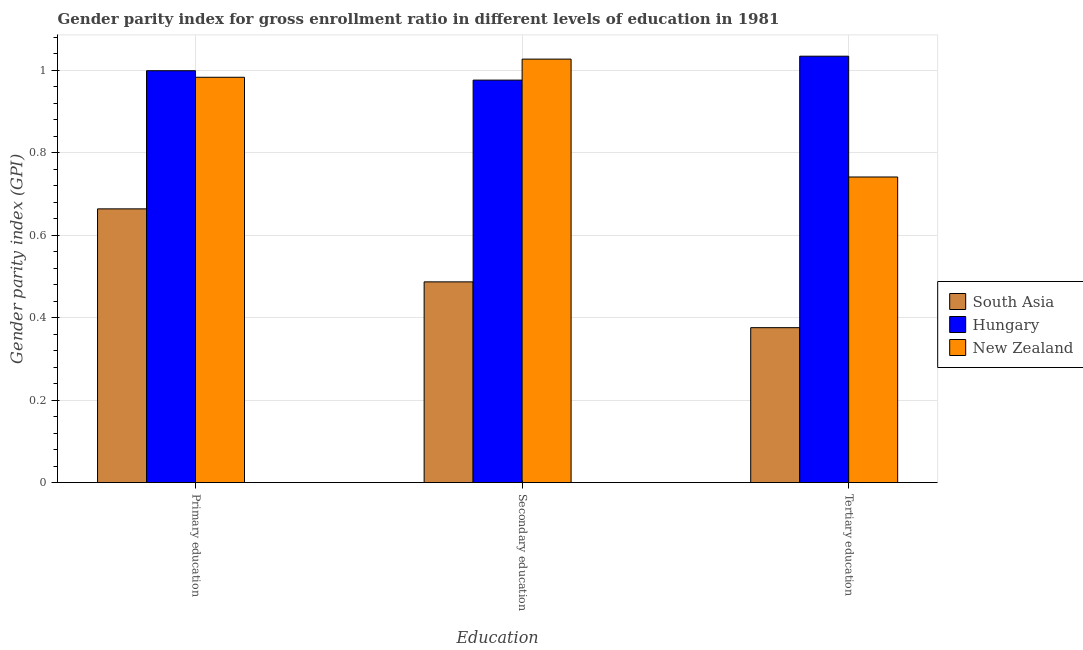How many different coloured bars are there?
Provide a succinct answer. 3. Are the number of bars on each tick of the X-axis equal?
Keep it short and to the point. Yes. How many bars are there on the 1st tick from the left?
Your response must be concise. 3. How many bars are there on the 3rd tick from the right?
Offer a very short reply. 3. What is the label of the 1st group of bars from the left?
Offer a very short reply. Primary education. What is the gender parity index in secondary education in New Zealand?
Offer a very short reply. 1.03. Across all countries, what is the maximum gender parity index in primary education?
Offer a terse response. 1. Across all countries, what is the minimum gender parity index in tertiary education?
Keep it short and to the point. 0.38. In which country was the gender parity index in primary education maximum?
Make the answer very short. Hungary. What is the total gender parity index in primary education in the graph?
Your response must be concise. 2.64. What is the difference between the gender parity index in tertiary education in New Zealand and that in Hungary?
Your answer should be very brief. -0.29. What is the difference between the gender parity index in primary education in New Zealand and the gender parity index in tertiary education in South Asia?
Ensure brevity in your answer.  0.61. What is the average gender parity index in tertiary education per country?
Ensure brevity in your answer.  0.72. What is the difference between the gender parity index in primary education and gender parity index in tertiary education in New Zealand?
Give a very brief answer. 0.24. What is the ratio of the gender parity index in tertiary education in South Asia to that in Hungary?
Offer a very short reply. 0.36. Is the gender parity index in tertiary education in New Zealand less than that in Hungary?
Give a very brief answer. Yes. What is the difference between the highest and the second highest gender parity index in primary education?
Offer a terse response. 0.02. What is the difference between the highest and the lowest gender parity index in tertiary education?
Offer a very short reply. 0.66. Is the sum of the gender parity index in tertiary education in Hungary and New Zealand greater than the maximum gender parity index in primary education across all countries?
Keep it short and to the point. Yes. What does the 3rd bar from the left in Tertiary education represents?
Provide a succinct answer. New Zealand. What does the 2nd bar from the right in Tertiary education represents?
Your response must be concise. Hungary. How many bars are there?
Offer a very short reply. 9. How many countries are there in the graph?
Offer a very short reply. 3. What is the difference between two consecutive major ticks on the Y-axis?
Provide a short and direct response. 0.2. Does the graph contain any zero values?
Your response must be concise. No. Does the graph contain grids?
Keep it short and to the point. Yes. How many legend labels are there?
Offer a very short reply. 3. How are the legend labels stacked?
Offer a terse response. Vertical. What is the title of the graph?
Your answer should be compact. Gender parity index for gross enrollment ratio in different levels of education in 1981. Does "Hong Kong" appear as one of the legend labels in the graph?
Your response must be concise. No. What is the label or title of the X-axis?
Provide a short and direct response. Education. What is the label or title of the Y-axis?
Provide a short and direct response. Gender parity index (GPI). What is the Gender parity index (GPI) in South Asia in Primary education?
Offer a terse response. 0.66. What is the Gender parity index (GPI) in Hungary in Primary education?
Your answer should be compact. 1. What is the Gender parity index (GPI) in New Zealand in Primary education?
Provide a short and direct response. 0.98. What is the Gender parity index (GPI) in South Asia in Secondary education?
Offer a very short reply. 0.49. What is the Gender parity index (GPI) of Hungary in Secondary education?
Your answer should be very brief. 0.98. What is the Gender parity index (GPI) of New Zealand in Secondary education?
Give a very brief answer. 1.03. What is the Gender parity index (GPI) in South Asia in Tertiary education?
Offer a very short reply. 0.38. What is the Gender parity index (GPI) in Hungary in Tertiary education?
Keep it short and to the point. 1.03. What is the Gender parity index (GPI) in New Zealand in Tertiary education?
Keep it short and to the point. 0.74. Across all Education, what is the maximum Gender parity index (GPI) of South Asia?
Give a very brief answer. 0.66. Across all Education, what is the maximum Gender parity index (GPI) in Hungary?
Offer a very short reply. 1.03. Across all Education, what is the maximum Gender parity index (GPI) of New Zealand?
Give a very brief answer. 1.03. Across all Education, what is the minimum Gender parity index (GPI) of South Asia?
Your answer should be very brief. 0.38. Across all Education, what is the minimum Gender parity index (GPI) in Hungary?
Your answer should be very brief. 0.98. Across all Education, what is the minimum Gender parity index (GPI) in New Zealand?
Give a very brief answer. 0.74. What is the total Gender parity index (GPI) in South Asia in the graph?
Your answer should be compact. 1.53. What is the total Gender parity index (GPI) in Hungary in the graph?
Make the answer very short. 3.01. What is the total Gender parity index (GPI) in New Zealand in the graph?
Give a very brief answer. 2.75. What is the difference between the Gender parity index (GPI) in South Asia in Primary education and that in Secondary education?
Offer a very short reply. 0.18. What is the difference between the Gender parity index (GPI) in Hungary in Primary education and that in Secondary education?
Keep it short and to the point. 0.02. What is the difference between the Gender parity index (GPI) in New Zealand in Primary education and that in Secondary education?
Provide a succinct answer. -0.04. What is the difference between the Gender parity index (GPI) in South Asia in Primary education and that in Tertiary education?
Make the answer very short. 0.29. What is the difference between the Gender parity index (GPI) of Hungary in Primary education and that in Tertiary education?
Your answer should be very brief. -0.04. What is the difference between the Gender parity index (GPI) of New Zealand in Primary education and that in Tertiary education?
Provide a short and direct response. 0.24. What is the difference between the Gender parity index (GPI) of South Asia in Secondary education and that in Tertiary education?
Your answer should be compact. 0.11. What is the difference between the Gender parity index (GPI) in Hungary in Secondary education and that in Tertiary education?
Make the answer very short. -0.06. What is the difference between the Gender parity index (GPI) of New Zealand in Secondary education and that in Tertiary education?
Provide a short and direct response. 0.29. What is the difference between the Gender parity index (GPI) of South Asia in Primary education and the Gender parity index (GPI) of Hungary in Secondary education?
Provide a short and direct response. -0.31. What is the difference between the Gender parity index (GPI) in South Asia in Primary education and the Gender parity index (GPI) in New Zealand in Secondary education?
Ensure brevity in your answer.  -0.36. What is the difference between the Gender parity index (GPI) of Hungary in Primary education and the Gender parity index (GPI) of New Zealand in Secondary education?
Your answer should be very brief. -0.03. What is the difference between the Gender parity index (GPI) of South Asia in Primary education and the Gender parity index (GPI) of Hungary in Tertiary education?
Keep it short and to the point. -0.37. What is the difference between the Gender parity index (GPI) in South Asia in Primary education and the Gender parity index (GPI) in New Zealand in Tertiary education?
Give a very brief answer. -0.08. What is the difference between the Gender parity index (GPI) of Hungary in Primary education and the Gender parity index (GPI) of New Zealand in Tertiary education?
Provide a succinct answer. 0.26. What is the difference between the Gender parity index (GPI) in South Asia in Secondary education and the Gender parity index (GPI) in Hungary in Tertiary education?
Provide a succinct answer. -0.55. What is the difference between the Gender parity index (GPI) in South Asia in Secondary education and the Gender parity index (GPI) in New Zealand in Tertiary education?
Offer a very short reply. -0.25. What is the difference between the Gender parity index (GPI) of Hungary in Secondary education and the Gender parity index (GPI) of New Zealand in Tertiary education?
Your response must be concise. 0.23. What is the average Gender parity index (GPI) of South Asia per Education?
Your answer should be compact. 0.51. What is the average Gender parity index (GPI) in New Zealand per Education?
Ensure brevity in your answer.  0.92. What is the difference between the Gender parity index (GPI) in South Asia and Gender parity index (GPI) in Hungary in Primary education?
Give a very brief answer. -0.33. What is the difference between the Gender parity index (GPI) of South Asia and Gender parity index (GPI) of New Zealand in Primary education?
Make the answer very short. -0.32. What is the difference between the Gender parity index (GPI) of Hungary and Gender parity index (GPI) of New Zealand in Primary education?
Give a very brief answer. 0.02. What is the difference between the Gender parity index (GPI) in South Asia and Gender parity index (GPI) in Hungary in Secondary education?
Your response must be concise. -0.49. What is the difference between the Gender parity index (GPI) in South Asia and Gender parity index (GPI) in New Zealand in Secondary education?
Offer a terse response. -0.54. What is the difference between the Gender parity index (GPI) of Hungary and Gender parity index (GPI) of New Zealand in Secondary education?
Give a very brief answer. -0.05. What is the difference between the Gender parity index (GPI) in South Asia and Gender parity index (GPI) in Hungary in Tertiary education?
Ensure brevity in your answer.  -0.66. What is the difference between the Gender parity index (GPI) of South Asia and Gender parity index (GPI) of New Zealand in Tertiary education?
Provide a short and direct response. -0.37. What is the difference between the Gender parity index (GPI) in Hungary and Gender parity index (GPI) in New Zealand in Tertiary education?
Provide a succinct answer. 0.29. What is the ratio of the Gender parity index (GPI) of South Asia in Primary education to that in Secondary education?
Your answer should be compact. 1.36. What is the ratio of the Gender parity index (GPI) in Hungary in Primary education to that in Secondary education?
Your response must be concise. 1.02. What is the ratio of the Gender parity index (GPI) in New Zealand in Primary education to that in Secondary education?
Your answer should be very brief. 0.96. What is the ratio of the Gender parity index (GPI) of South Asia in Primary education to that in Tertiary education?
Keep it short and to the point. 1.77. What is the ratio of the Gender parity index (GPI) of Hungary in Primary education to that in Tertiary education?
Provide a succinct answer. 0.97. What is the ratio of the Gender parity index (GPI) of New Zealand in Primary education to that in Tertiary education?
Provide a short and direct response. 1.33. What is the ratio of the Gender parity index (GPI) of South Asia in Secondary education to that in Tertiary education?
Make the answer very short. 1.3. What is the ratio of the Gender parity index (GPI) in Hungary in Secondary education to that in Tertiary education?
Your answer should be very brief. 0.94. What is the ratio of the Gender parity index (GPI) of New Zealand in Secondary education to that in Tertiary education?
Ensure brevity in your answer.  1.39. What is the difference between the highest and the second highest Gender parity index (GPI) in South Asia?
Your response must be concise. 0.18. What is the difference between the highest and the second highest Gender parity index (GPI) of Hungary?
Your answer should be compact. 0.04. What is the difference between the highest and the second highest Gender parity index (GPI) in New Zealand?
Offer a very short reply. 0.04. What is the difference between the highest and the lowest Gender parity index (GPI) of South Asia?
Make the answer very short. 0.29. What is the difference between the highest and the lowest Gender parity index (GPI) of Hungary?
Your answer should be compact. 0.06. What is the difference between the highest and the lowest Gender parity index (GPI) in New Zealand?
Provide a short and direct response. 0.29. 